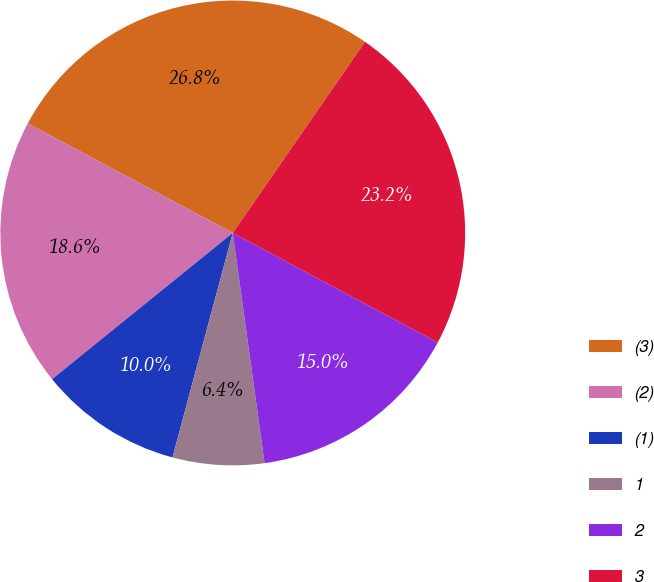<chart> <loc_0><loc_0><loc_500><loc_500><pie_chart><fcel>(3)<fcel>(2)<fcel>(1)<fcel>1<fcel>2<fcel>3<nl><fcel>26.82%<fcel>18.64%<fcel>10.0%<fcel>6.36%<fcel>15.0%<fcel>23.18%<nl></chart> 